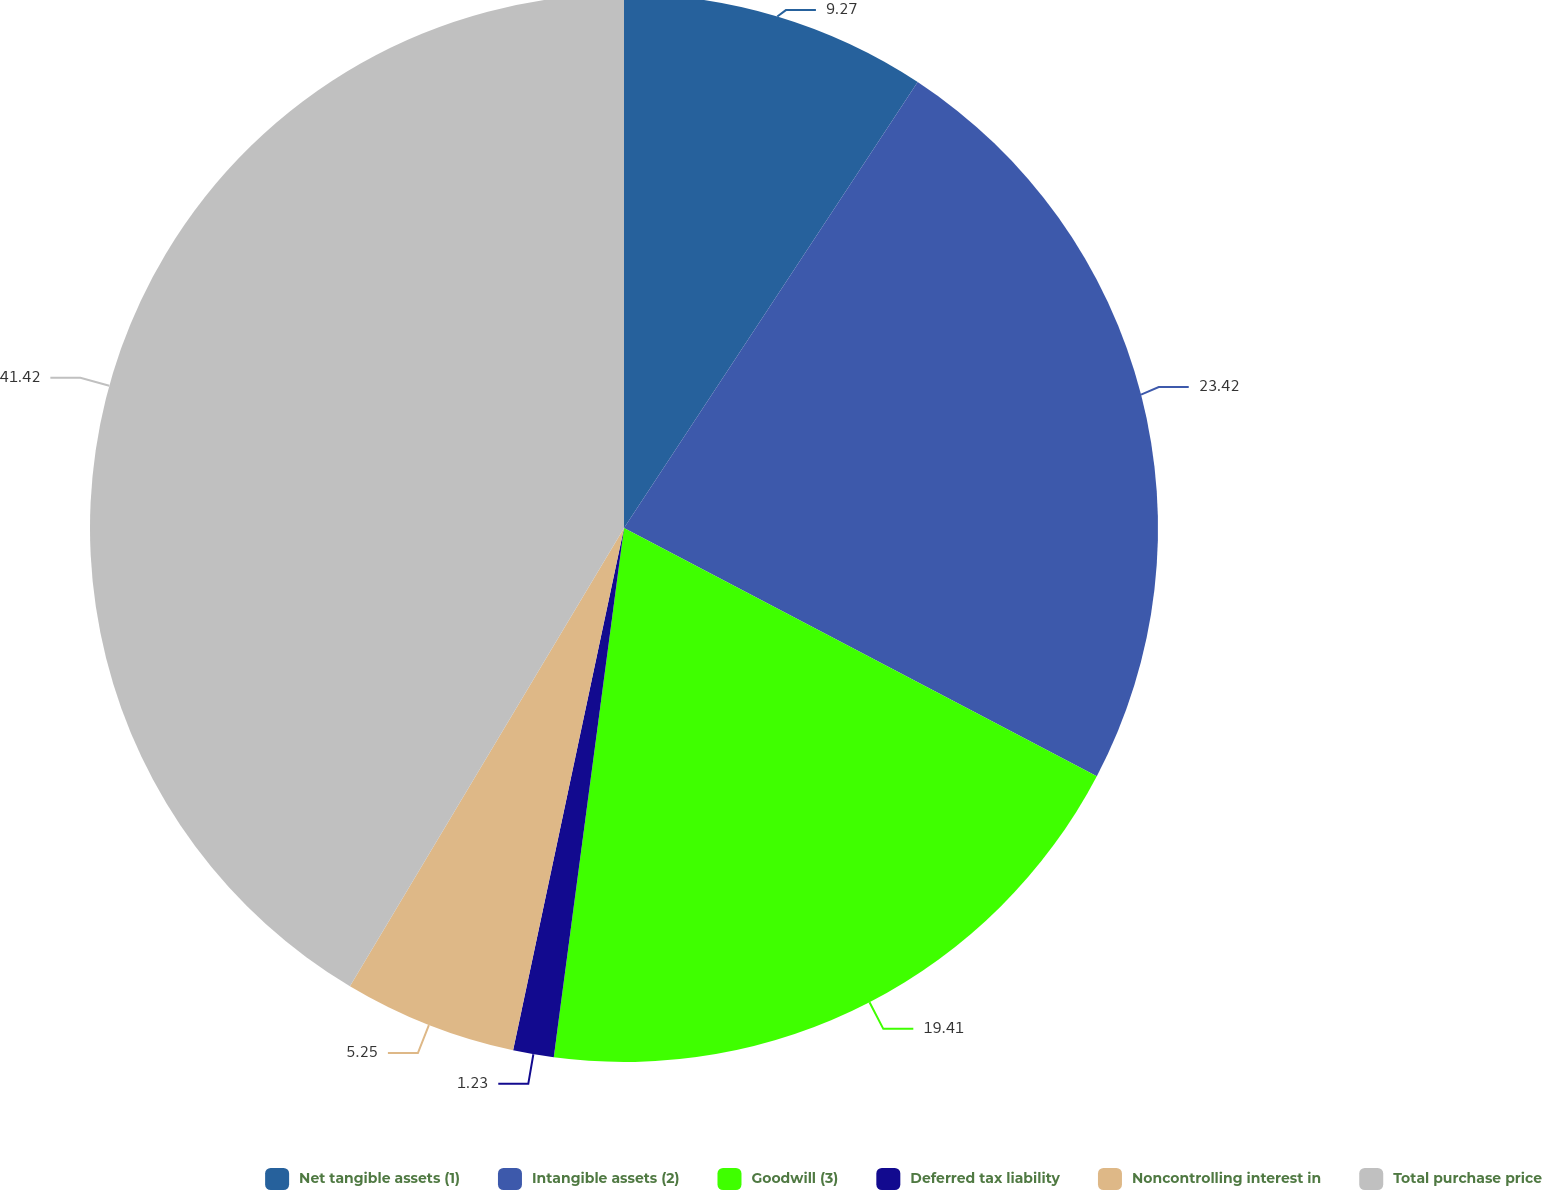<chart> <loc_0><loc_0><loc_500><loc_500><pie_chart><fcel>Net tangible assets (1)<fcel>Intangible assets (2)<fcel>Goodwill (3)<fcel>Deferred tax liability<fcel>Noncontrolling interest in<fcel>Total purchase price<nl><fcel>9.27%<fcel>23.43%<fcel>19.41%<fcel>1.23%<fcel>5.25%<fcel>41.43%<nl></chart> 